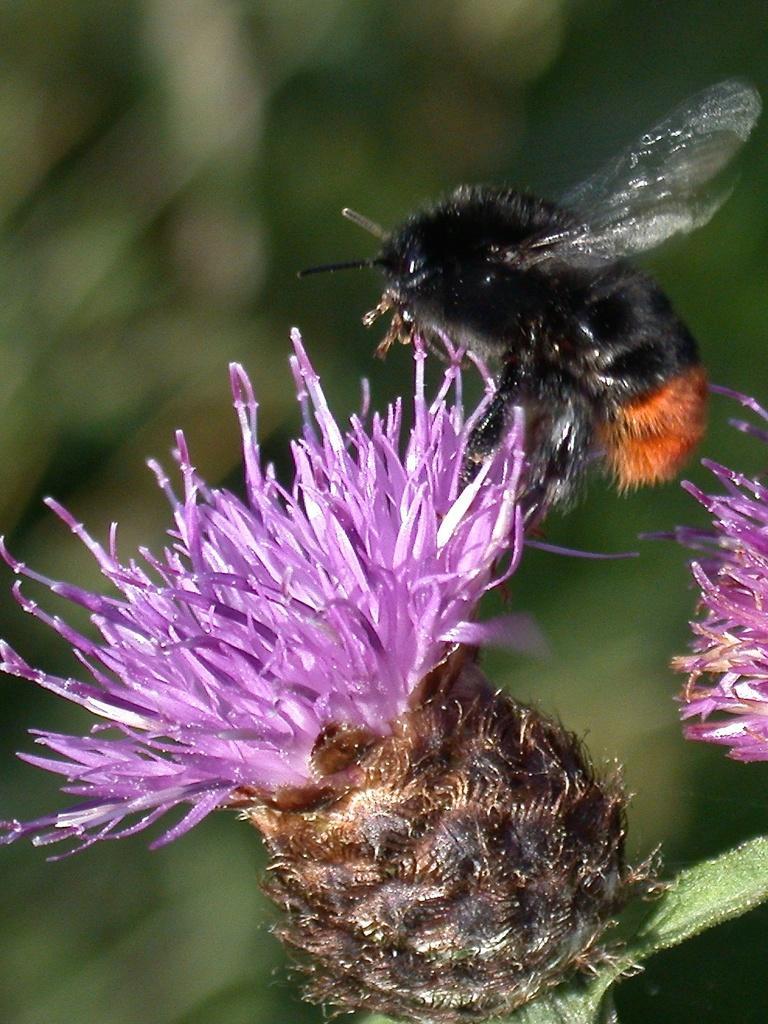Could you give a brief overview of what you see in this image? In front of the image there is an insect on the flower. Behind them there is a blur background. 